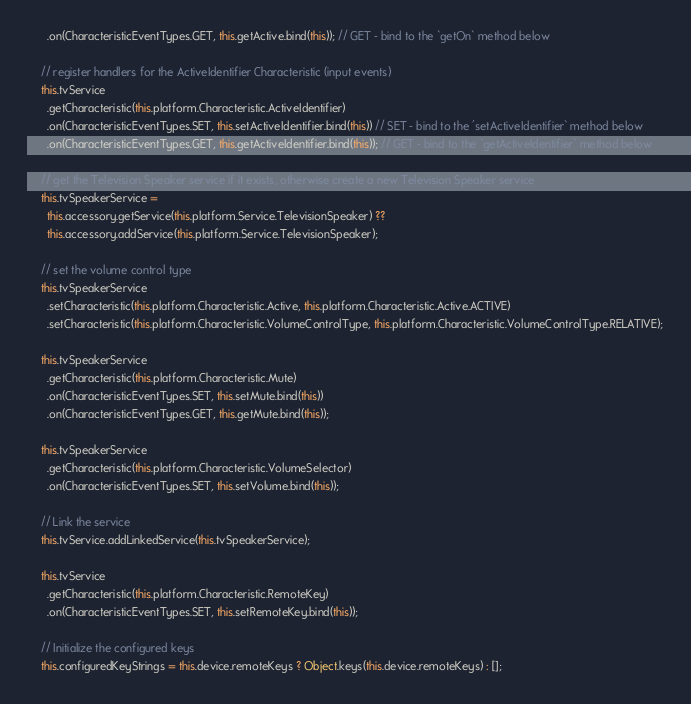Convert code to text. <code><loc_0><loc_0><loc_500><loc_500><_TypeScript_>      .on(CharacteristicEventTypes.GET, this.getActive.bind(this)); // GET - bind to the `getOn` method below

    // register handlers for the ActiveIdentifier Characteristic (input events)
    this.tvService
      .getCharacteristic(this.platform.Characteristic.ActiveIdentifier)
      .on(CharacteristicEventTypes.SET, this.setActiveIdentifier.bind(this)) // SET - bind to the 'setActiveIdentifier` method below
      .on(CharacteristicEventTypes.GET, this.getActiveIdentifier.bind(this)); // GET - bind to the `getActiveIdentifier` method below

    // get the Television Speaker service if it exists, otherwise create a new Television Speaker service
    this.tvSpeakerService =
      this.accessory.getService(this.platform.Service.TelevisionSpeaker) ??
      this.accessory.addService(this.platform.Service.TelevisionSpeaker);

    // set the volume control type
    this.tvSpeakerService
      .setCharacteristic(this.platform.Characteristic.Active, this.platform.Characteristic.Active.ACTIVE)
      .setCharacteristic(this.platform.Characteristic.VolumeControlType, this.platform.Characteristic.VolumeControlType.RELATIVE);

    this.tvSpeakerService
      .getCharacteristic(this.platform.Characteristic.Mute)
      .on(CharacteristicEventTypes.SET, this.setMute.bind(this))
      .on(CharacteristicEventTypes.GET, this.getMute.bind(this));

    this.tvSpeakerService
      .getCharacteristic(this.platform.Characteristic.VolumeSelector)
      .on(CharacteristicEventTypes.SET, this.setVolume.bind(this));

    // Link the service
    this.tvService.addLinkedService(this.tvSpeakerService);

    this.tvService
      .getCharacteristic(this.platform.Characteristic.RemoteKey)
      .on(CharacteristicEventTypes.SET, this.setRemoteKey.bind(this));

    // Initialize the configured keys
    this.configuredKeyStrings = this.device.remoteKeys ? Object.keys(this.device.remoteKeys) : [];</code> 